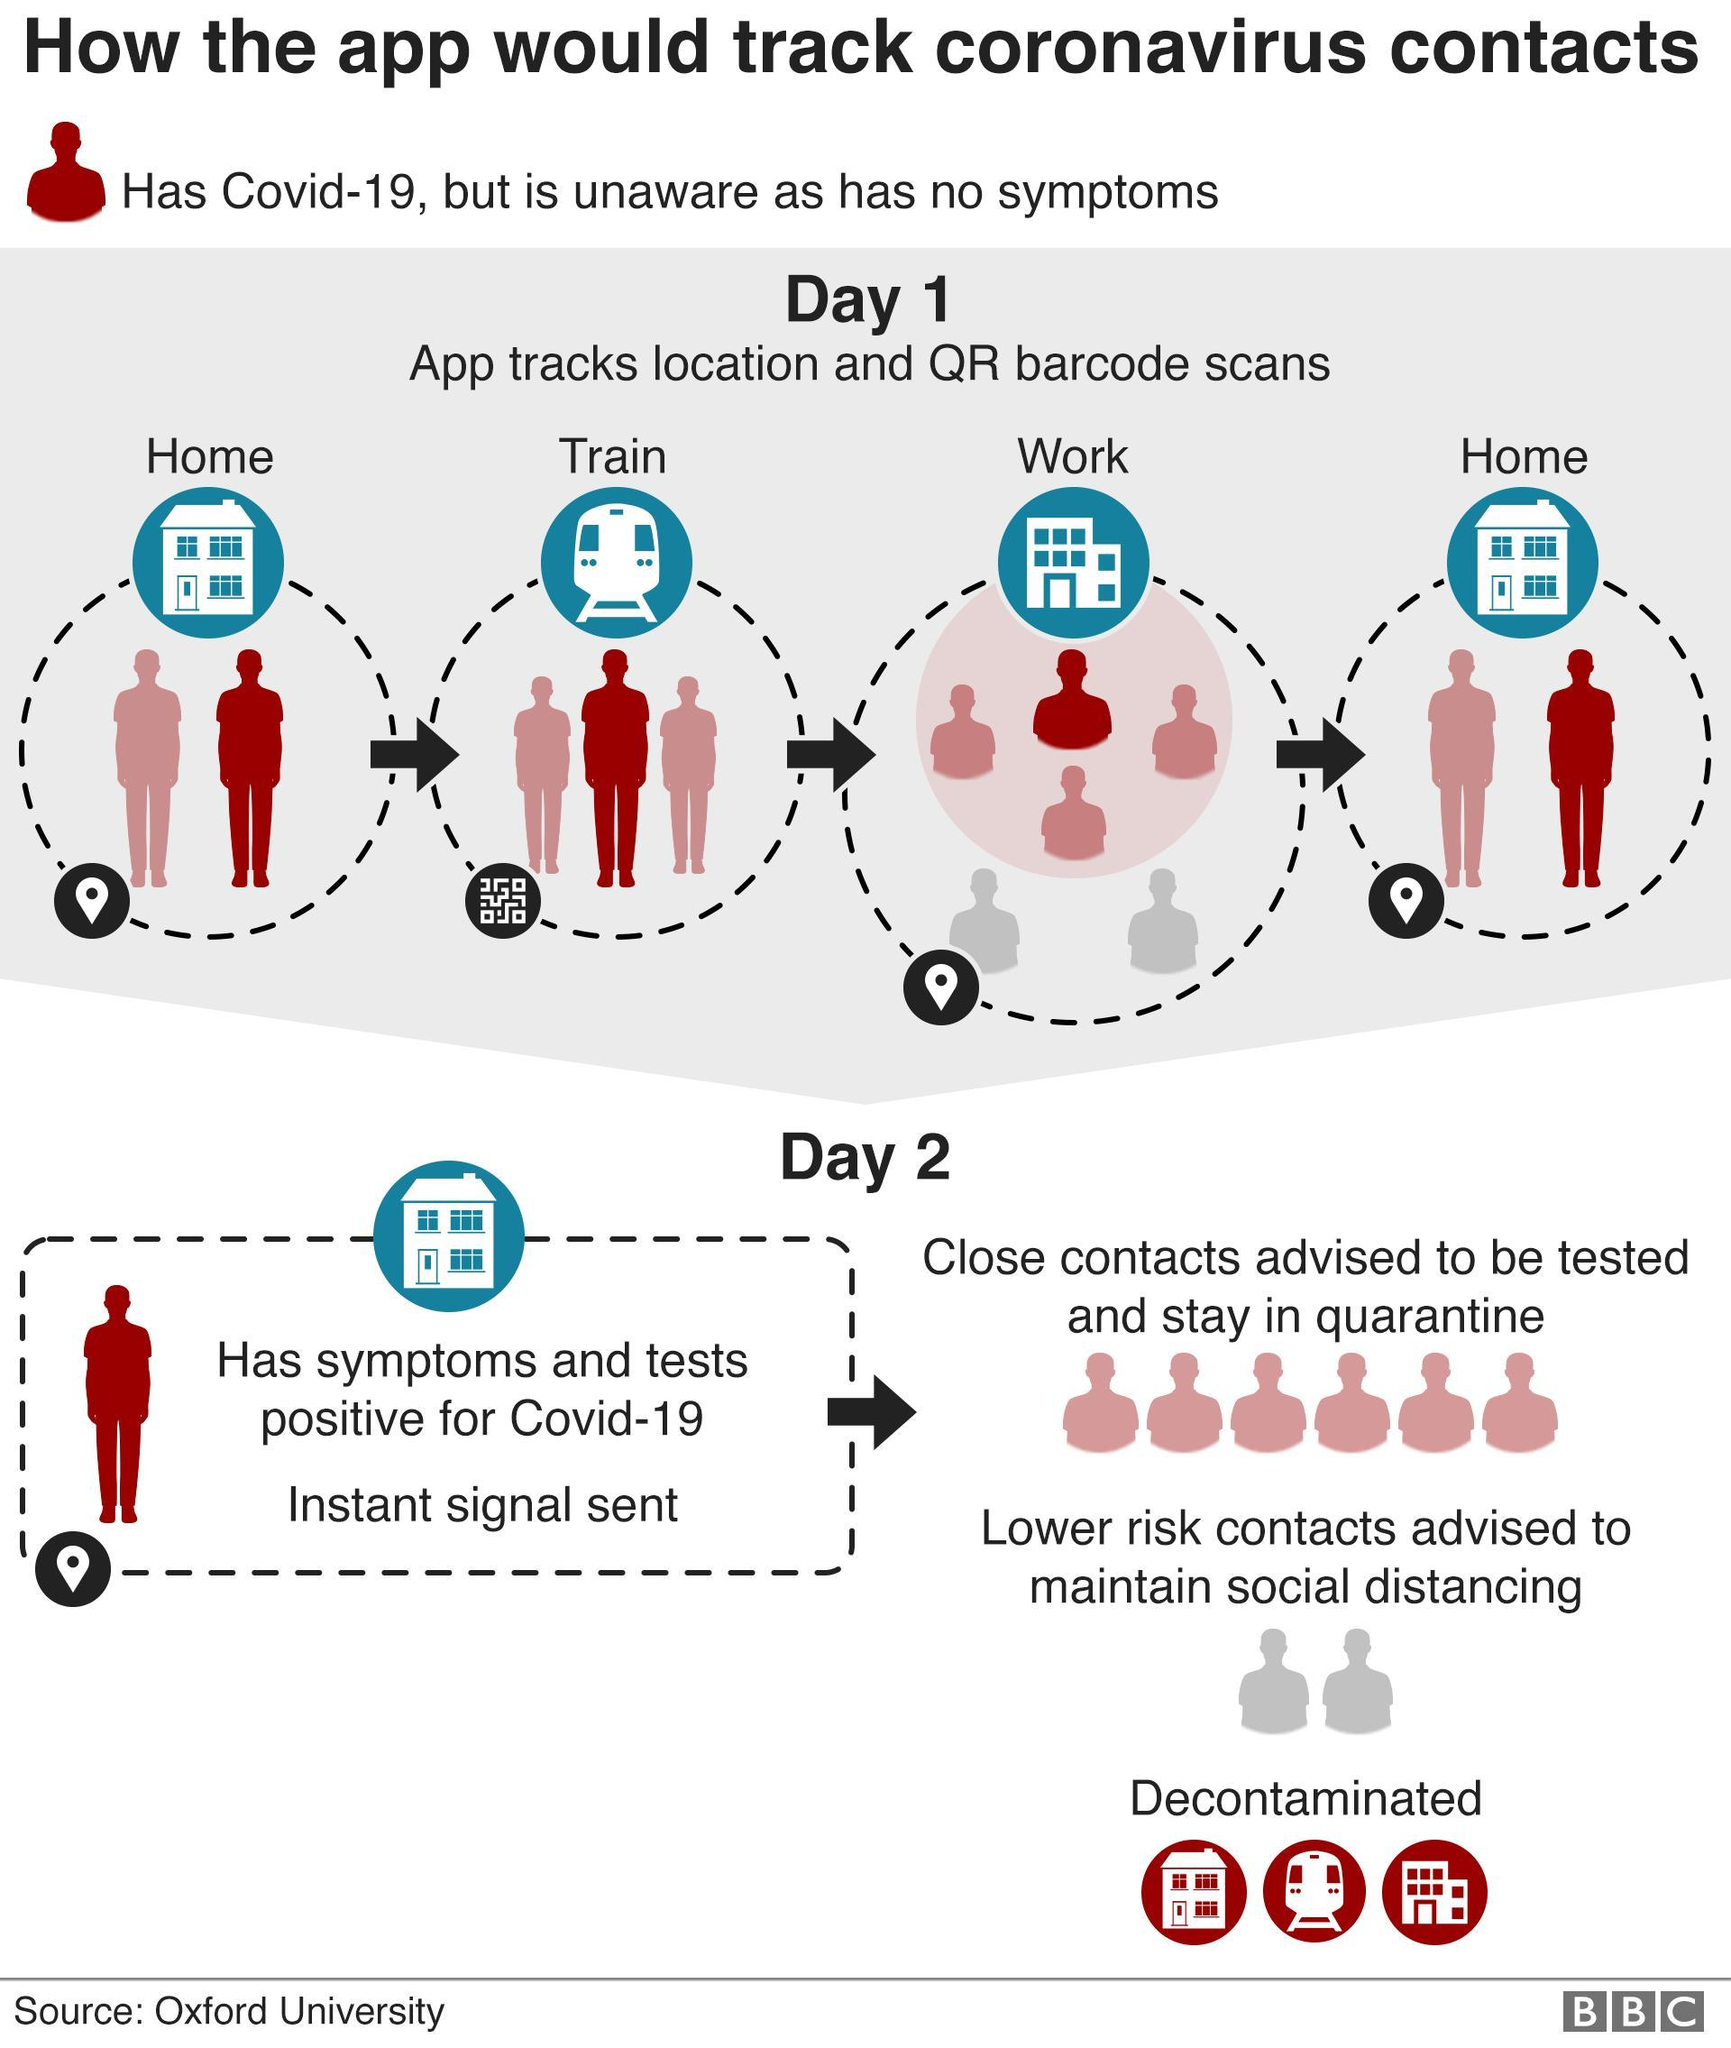If a person has symptoms and tested COVID positive, instant message is sent to which type of contacts?
Answer the question with a short phrase. Close contacts If a person has symptoms and tested COVID positive, how his contacts are differentiated? Close contacts, Low risk contacts In train how the app tracks COVID patient? QR barcode scans 